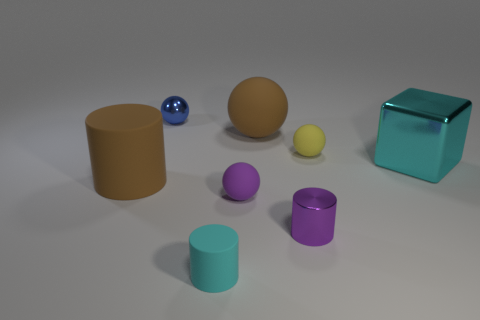There is a blue object that is the same size as the cyan rubber cylinder; what is its shape?
Ensure brevity in your answer.  Sphere. There is a shiny object left of the cyan rubber object; what is its size?
Offer a terse response. Small. Do the tiny cylinder that is to the right of the big brown matte sphere and the matte ball that is left of the big brown rubber sphere have the same color?
Ensure brevity in your answer.  Yes. What is the material of the big object behind the cyan thing on the right side of the tiny rubber object on the left side of the purple rubber thing?
Offer a terse response. Rubber. Is there a cyan thing of the same size as the metallic ball?
Make the answer very short. Yes. What material is the cyan object that is the same size as the brown matte cylinder?
Your response must be concise. Metal. There is a big brown thing that is on the right side of the cyan cylinder; what is its shape?
Make the answer very short. Sphere. Does the tiny sphere in front of the cyan shiny block have the same material as the large brown thing behind the large brown rubber cylinder?
Ensure brevity in your answer.  Yes. What number of other things have the same shape as the big cyan object?
Give a very brief answer. 0. There is a ball that is the same color as the large cylinder; what is its material?
Ensure brevity in your answer.  Rubber. 